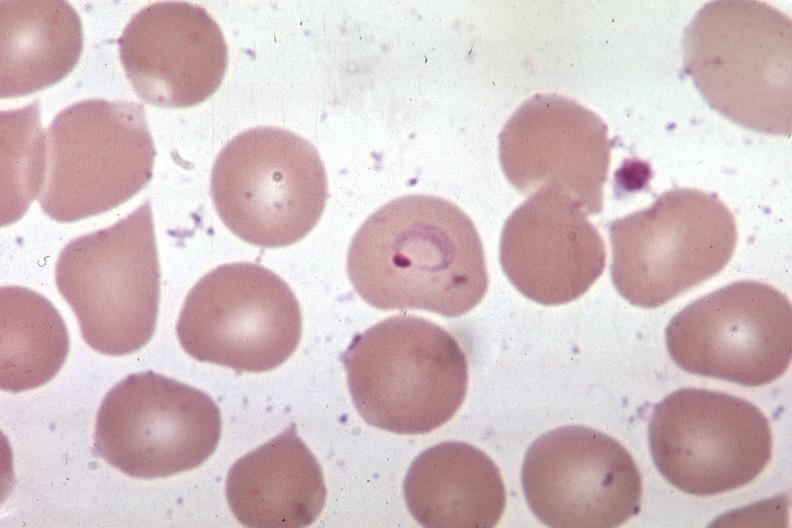does photo show wrights excellent?
Answer the question using a single word or phrase. No 